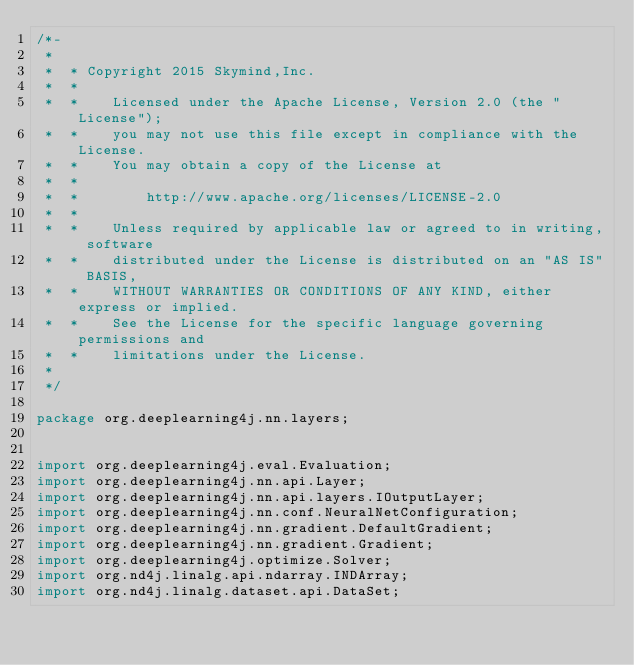Convert code to text. <code><loc_0><loc_0><loc_500><loc_500><_Java_>/*-
 *
 *  * Copyright 2015 Skymind,Inc.
 *  *
 *  *    Licensed under the Apache License, Version 2.0 (the "License");
 *  *    you may not use this file except in compliance with the License.
 *  *    You may obtain a copy of the License at
 *  *
 *  *        http://www.apache.org/licenses/LICENSE-2.0
 *  *
 *  *    Unless required by applicable law or agreed to in writing, software
 *  *    distributed under the License is distributed on an "AS IS" BASIS,
 *  *    WITHOUT WARRANTIES OR CONDITIONS OF ANY KIND, either express or implied.
 *  *    See the License for the specific language governing permissions and
 *  *    limitations under the License.
 *
 */

package org.deeplearning4j.nn.layers;


import org.deeplearning4j.eval.Evaluation;
import org.deeplearning4j.nn.api.Layer;
import org.deeplearning4j.nn.api.layers.IOutputLayer;
import org.deeplearning4j.nn.conf.NeuralNetConfiguration;
import org.deeplearning4j.nn.gradient.DefaultGradient;
import org.deeplearning4j.nn.gradient.Gradient;
import org.deeplearning4j.optimize.Solver;
import org.nd4j.linalg.api.ndarray.INDArray;
import org.nd4j.linalg.dataset.api.DataSet;</code> 